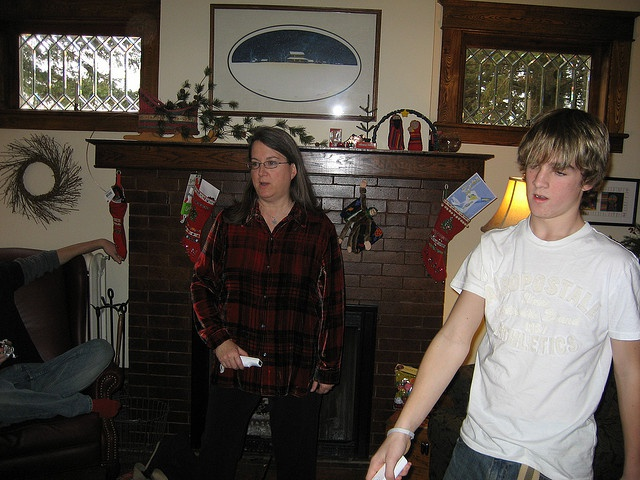Describe the objects in this image and their specific colors. I can see people in black, lightgray, darkgray, and gray tones, people in black, brown, and maroon tones, people in black, maroon, and gray tones, chair in black and gray tones, and remote in black, lightgray, gray, and darkgray tones in this image. 